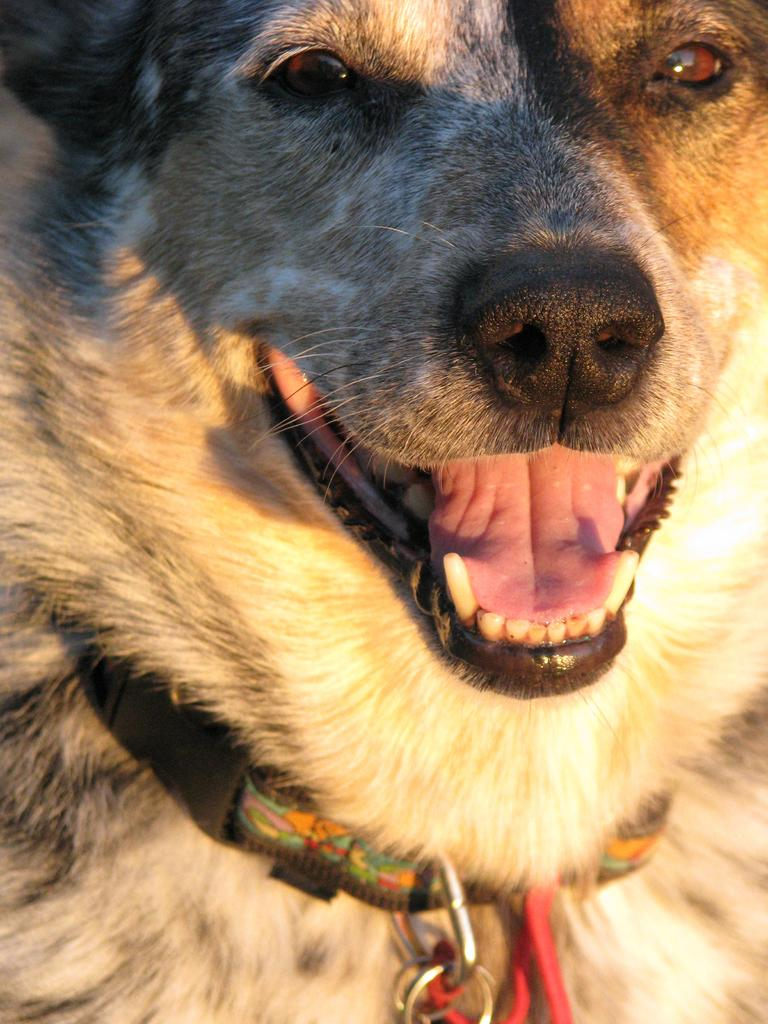What type of animal is in the image? There is a dog in the image. Can you describe any accessories the dog is wearing? The dog has a belt around its neck. What type of silk material is used to make the dog's collar in the image? There is no mention of silk or a collar in the image; the dog is wearing a belt. 